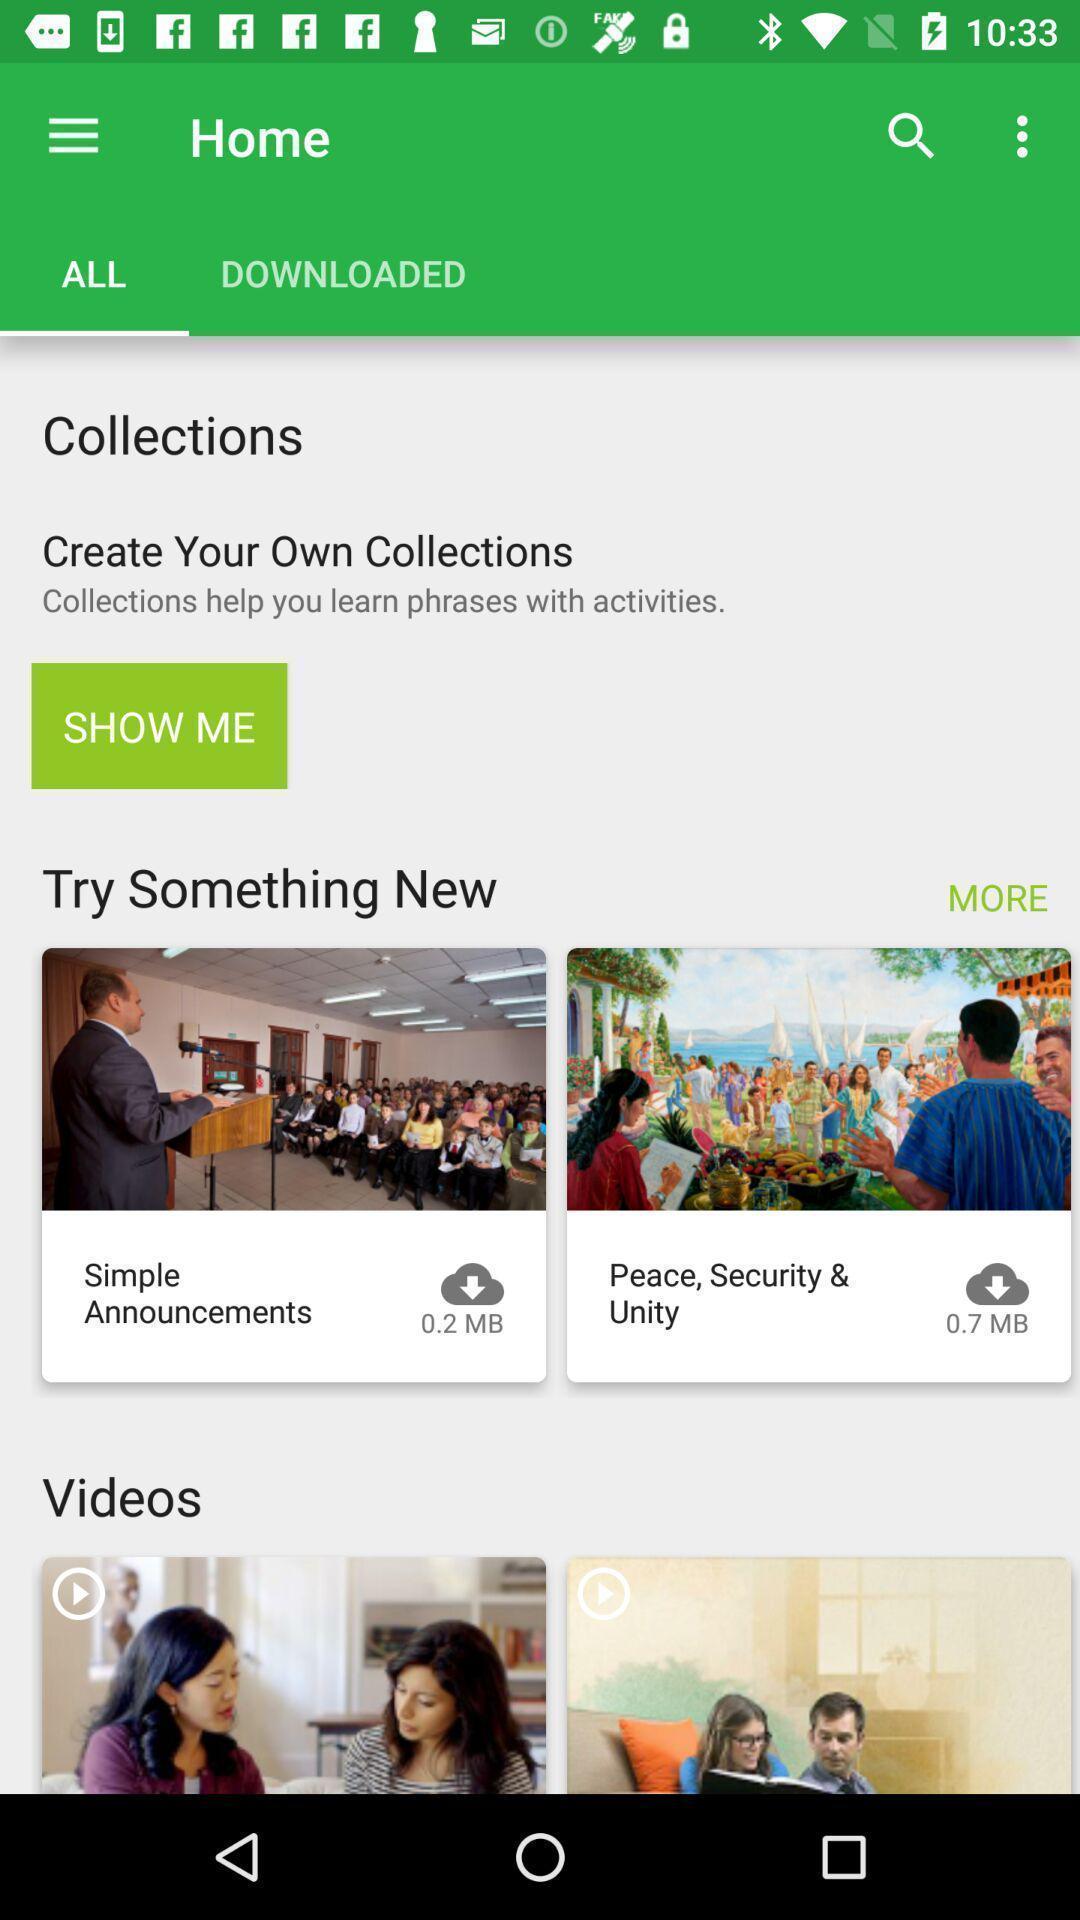Explain what's happening in this screen capture. Screen shows number of video collections. 